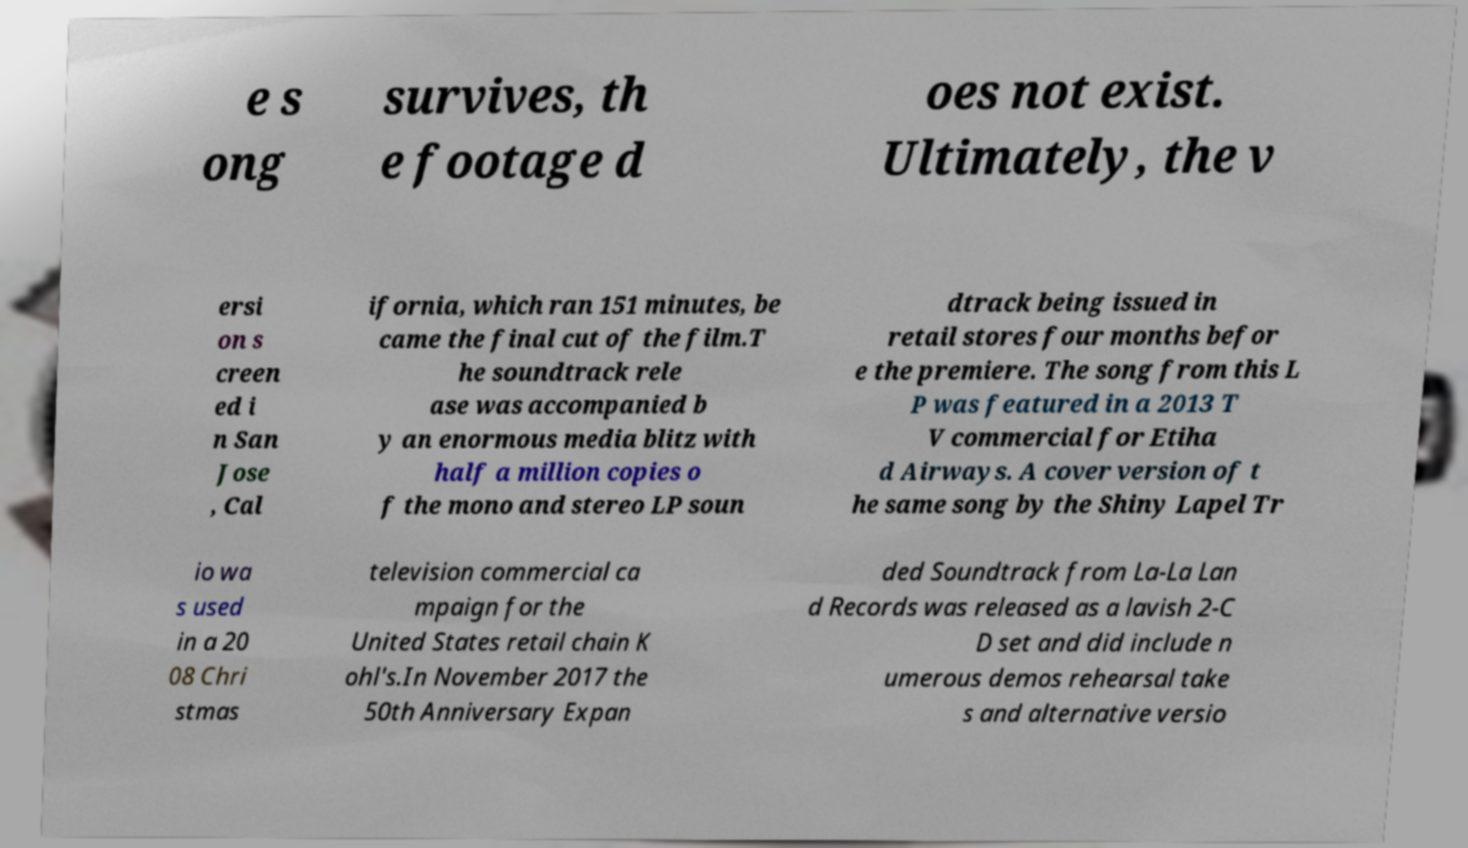Can you read and provide the text displayed in the image?This photo seems to have some interesting text. Can you extract and type it out for me? e s ong survives, th e footage d oes not exist. Ultimately, the v ersi on s creen ed i n San Jose , Cal ifornia, which ran 151 minutes, be came the final cut of the film.T he soundtrack rele ase was accompanied b y an enormous media blitz with half a million copies o f the mono and stereo LP soun dtrack being issued in retail stores four months befor e the premiere. The song from this L P was featured in a 2013 T V commercial for Etiha d Airways. A cover version of t he same song by the Shiny Lapel Tr io wa s used in a 20 08 Chri stmas television commercial ca mpaign for the United States retail chain K ohl's.In November 2017 the 50th Anniversary Expan ded Soundtrack from La-La Lan d Records was released as a lavish 2-C D set and did include n umerous demos rehearsal take s and alternative versio 